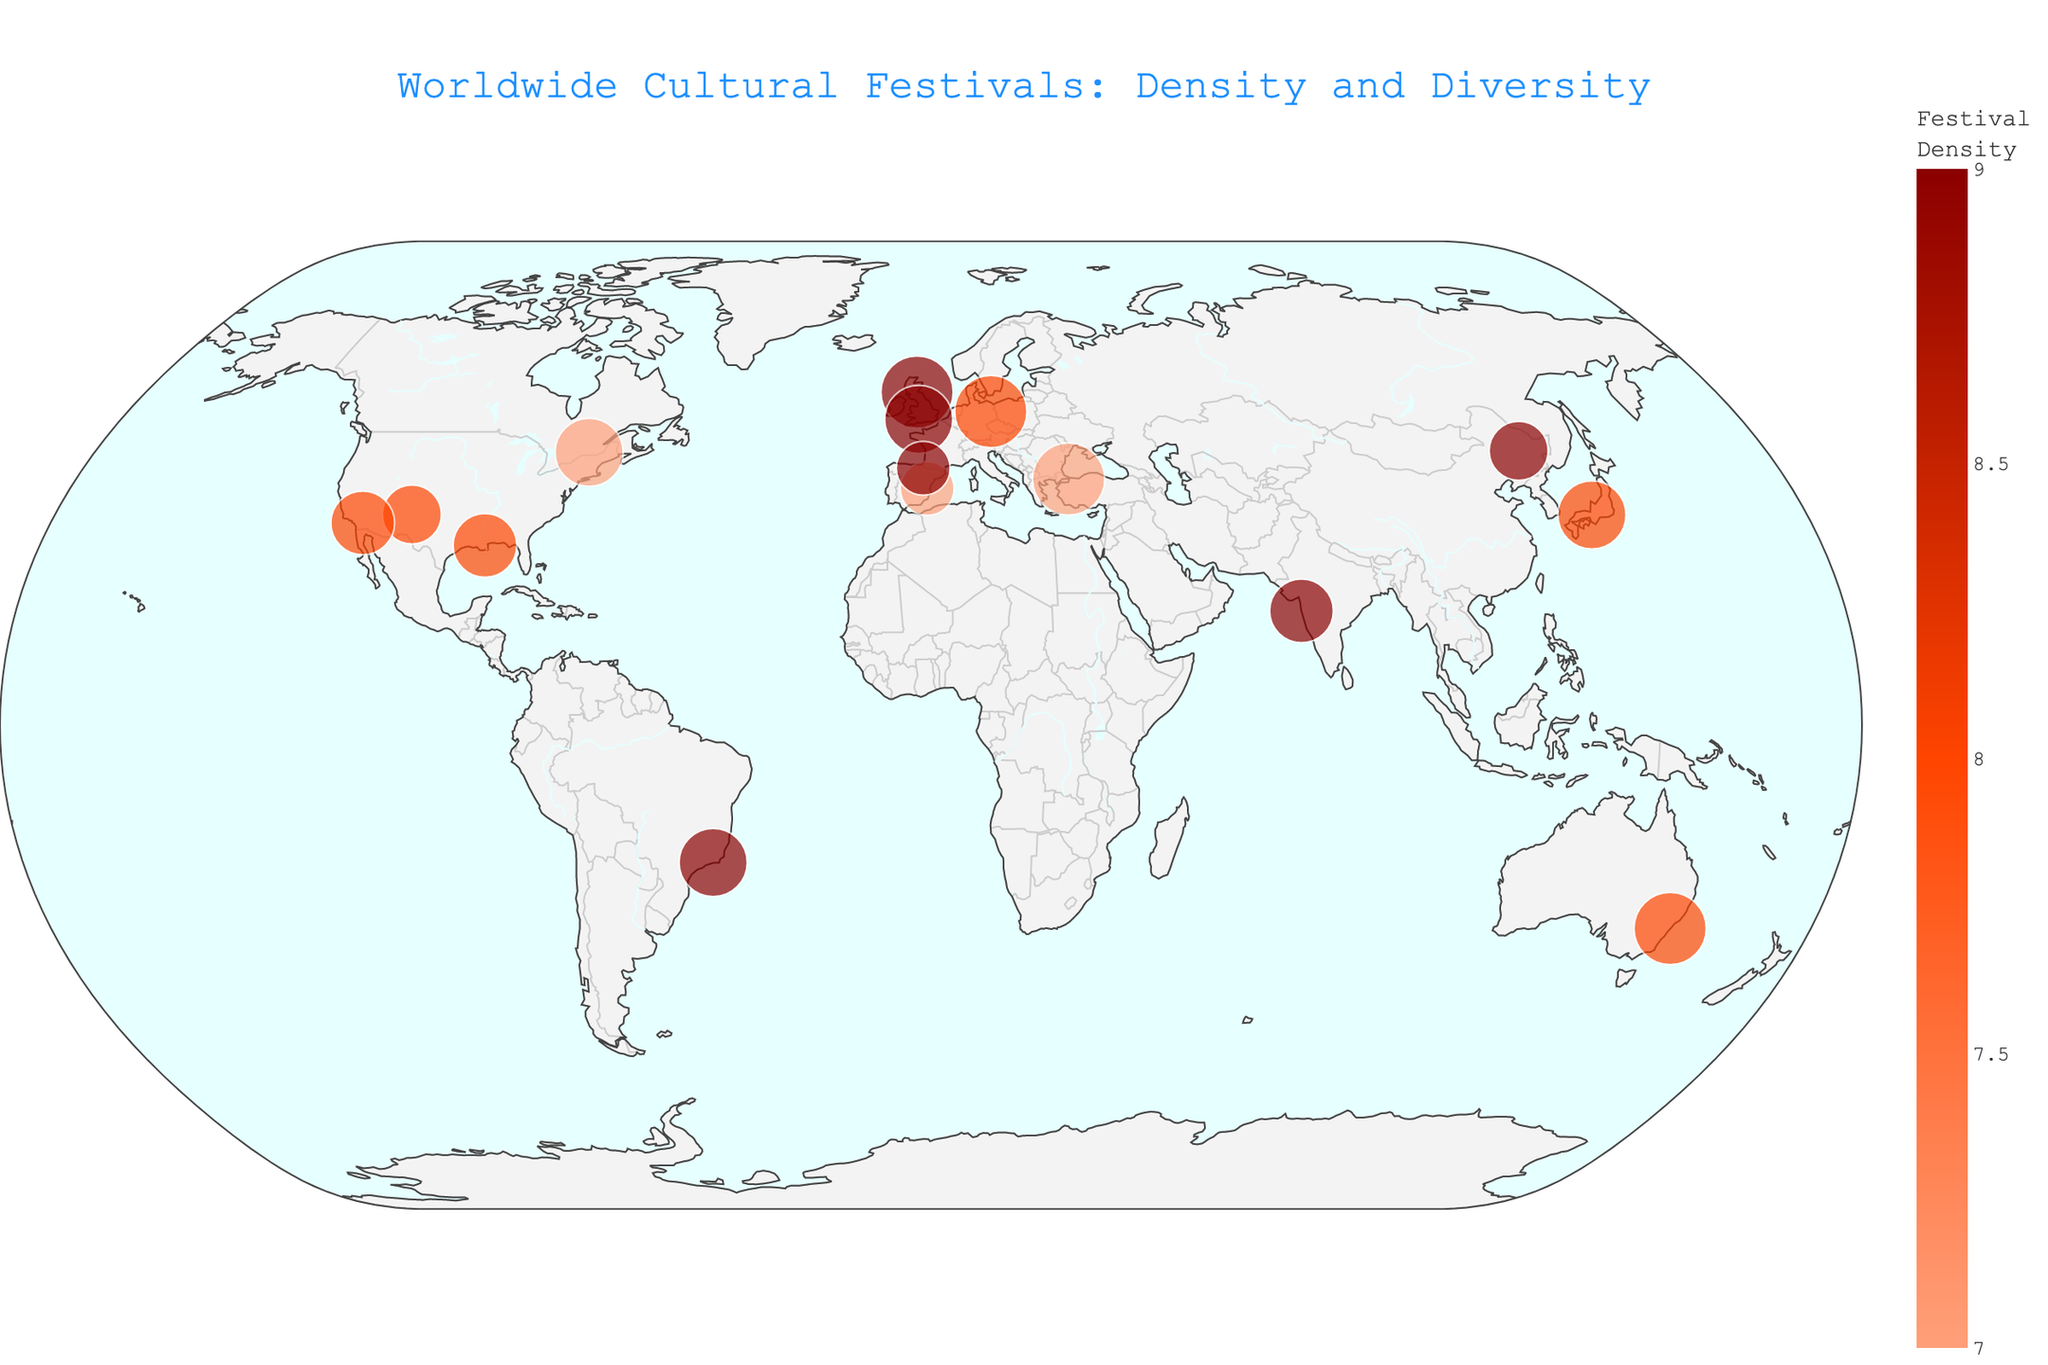What's the title of the map? Look at the top center of the map for a large text that describes the purpose of the figure. The title usually summarizes the visual.
Answer: "Worldwide Cultural Festivals: Density and Diversity" How many festivals have a density of 9? Count the distinct festival points on the map that have been colored with the highest density level, which is 9. The color bar on the side can help identify the density levels.
Answer: 6 Which festival is located in North America and has the highest diversity score? By examining the North America region on the map, identify the festival with the largest marker, representing the highest diversity score. Check the hover data for diversity scores.
Answer: "International Balloon Fiesta" in Albuquerque Compare the diversity score between the Carnival in Rio de Janeiro and the Gion Matsuri in Kyoto. Which one is higher? Identify both festivals on the map by their geographical locations and names. Compare the size of their markers, where larger ones indicate higher diversity scores.
Answer: "Gion Matsuri" in Kyoto Which region has the highest concentration of cultural festivals? Look for the region on the map with the highest number of festival markers closely located together. Also refer to the density colors on the map.
Answer: Europe What is the latitude and longitude of La Tomatina festival? Locate the La Tomatina festival on the map and note down its geographic coordinates displayed upon hovering over or through annotation.
Answer: "39.4189, -0.7902" How many types of festivals are represented on this map? Count the unique festival types listed in the hover data for different points on the map.
Answer: 11 types Which festival is characterized by a significant density but a relatively low diversity? Find the point that is marked with a high-density color but has a smaller marker size, typically indicating low diversity compared to its density.
Answer: "La Tomatina" in Buñol Which festival has the same diversity score as the “Glastonbury Festival”? Identify the diversity score of the Glastonbury Festival by its marker size. Then look for another festival with the same marker size (diversity score) on the map.
Answer: "Carnival" in Rio de Janeiro What is the range of diversity scores depicted on this map? Identify the smallest and largest marker sizes on the map to determine the range of diversity scores among all festivals.
Answer: 5 to 9 